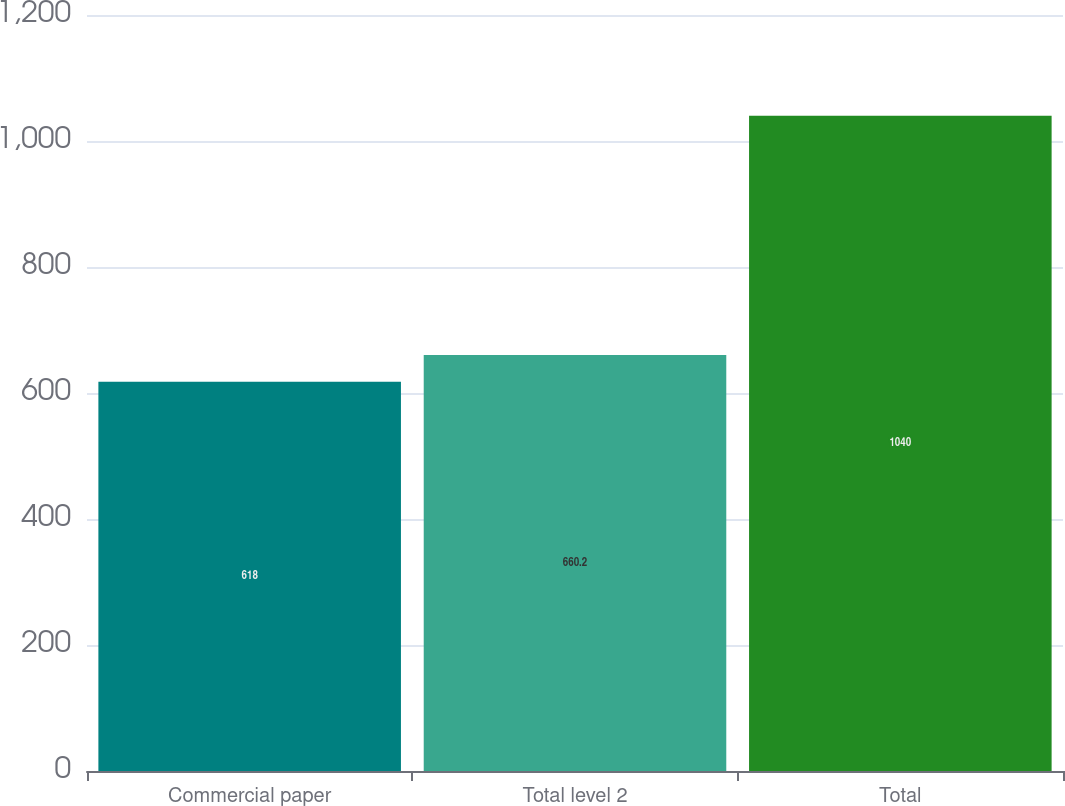Convert chart to OTSL. <chart><loc_0><loc_0><loc_500><loc_500><bar_chart><fcel>Commercial paper<fcel>Total level 2<fcel>Total<nl><fcel>618<fcel>660.2<fcel>1040<nl></chart> 